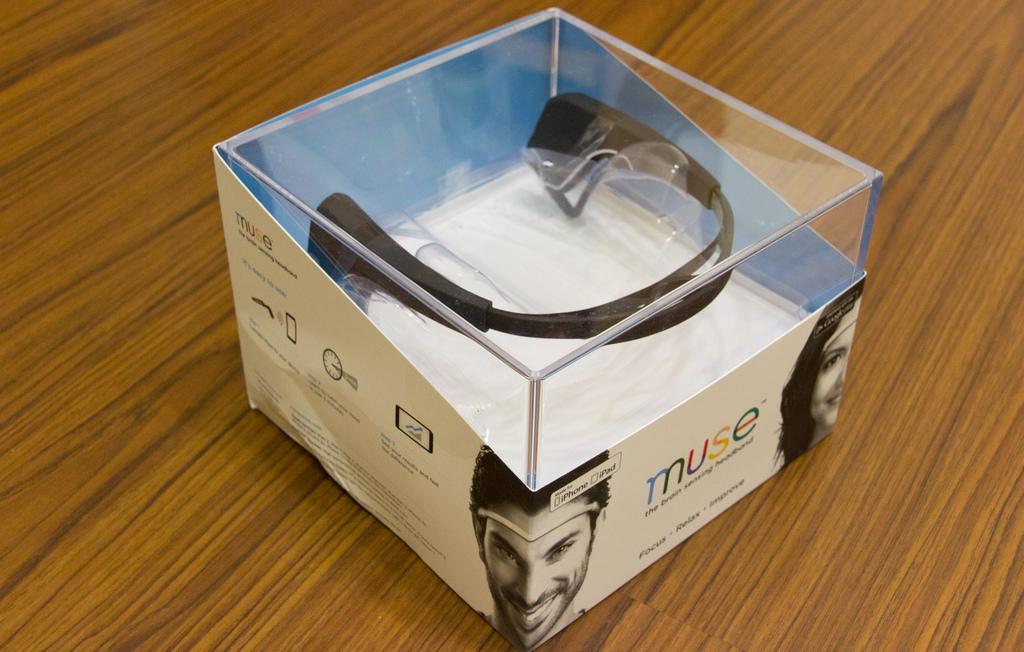Please provide a concise description of this image. In the center of the image we can see an object which is packed on the wall. 